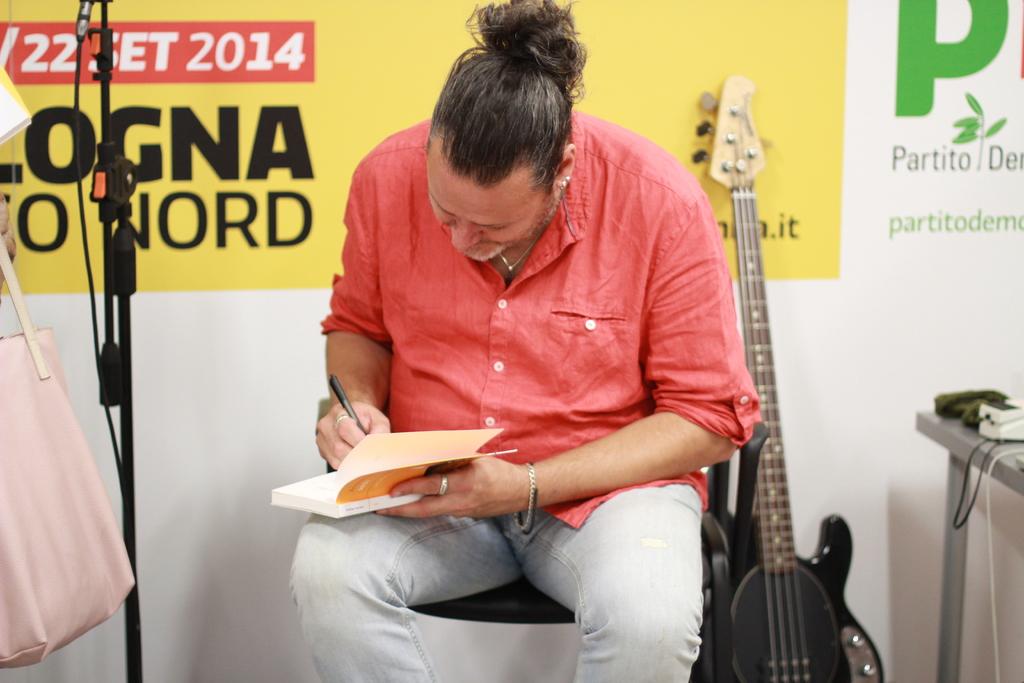What is the year written on the back?
Your response must be concise. 2014. 